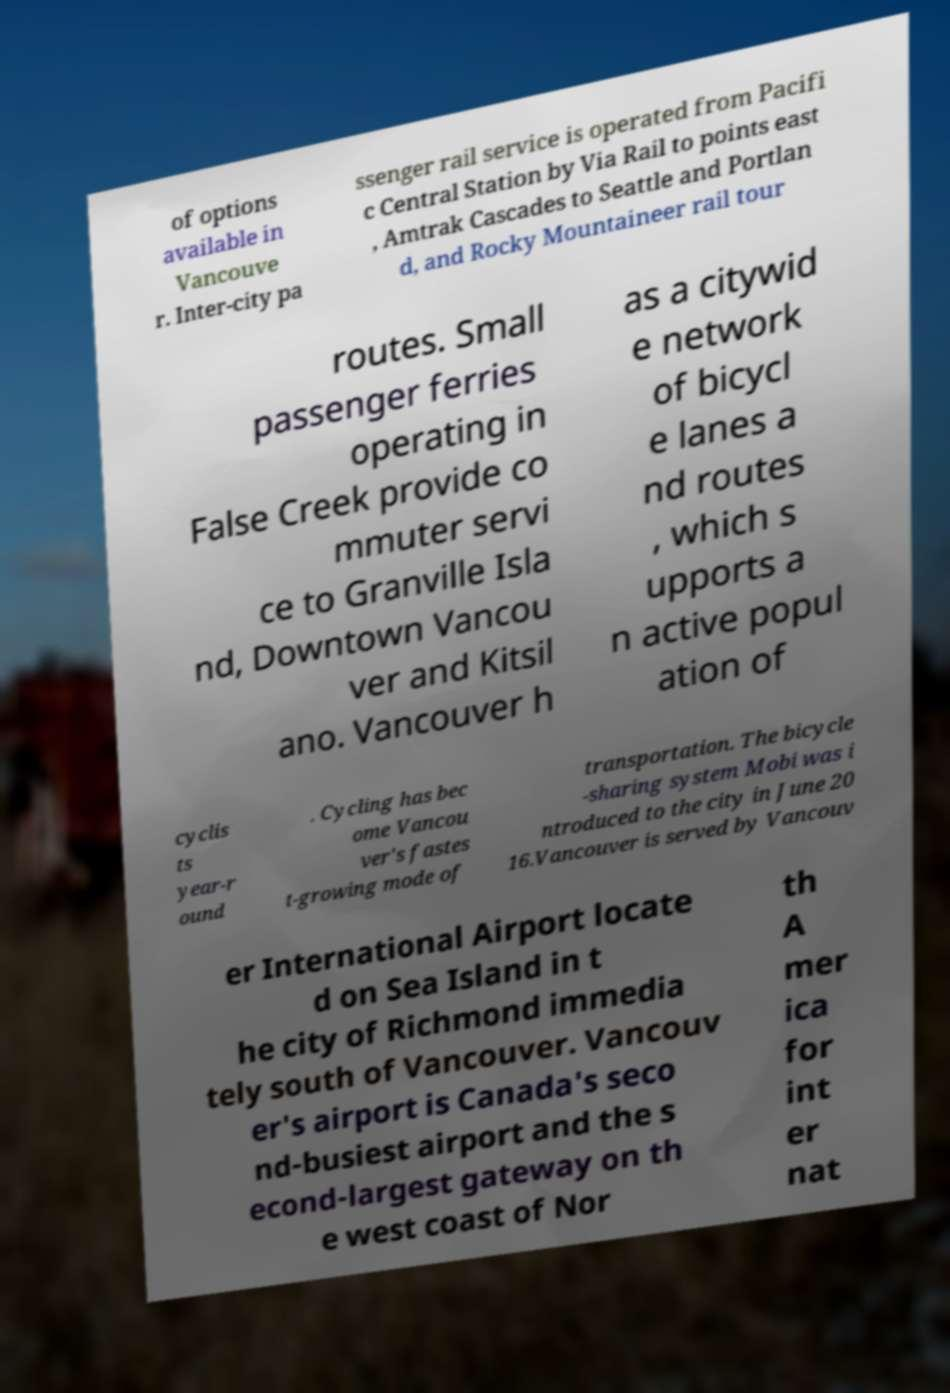Could you assist in decoding the text presented in this image and type it out clearly? of options available in Vancouve r. Inter-city pa ssenger rail service is operated from Pacifi c Central Station by Via Rail to points east , Amtrak Cascades to Seattle and Portlan d, and Rocky Mountaineer rail tour routes. Small passenger ferries operating in False Creek provide co mmuter servi ce to Granville Isla nd, Downtown Vancou ver and Kitsil ano. Vancouver h as a citywid e network of bicycl e lanes a nd routes , which s upports a n active popul ation of cyclis ts year-r ound . Cycling has bec ome Vancou ver's fastes t-growing mode of transportation. The bicycle -sharing system Mobi was i ntroduced to the city in June 20 16.Vancouver is served by Vancouv er International Airport locate d on Sea Island in t he city of Richmond immedia tely south of Vancouver. Vancouv er's airport is Canada's seco nd-busiest airport and the s econd-largest gateway on th e west coast of Nor th A mer ica for int er nat 